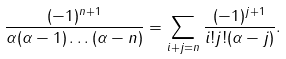Convert formula to latex. <formula><loc_0><loc_0><loc_500><loc_500>\frac { ( - 1 ) ^ { n + 1 } } { \alpha ( \alpha - 1 ) \dots ( \alpha - n ) } = \sum _ { i + j = n } \frac { ( - 1 ) ^ { j + 1 } } { i ! j ! ( \alpha - j ) } .</formula> 